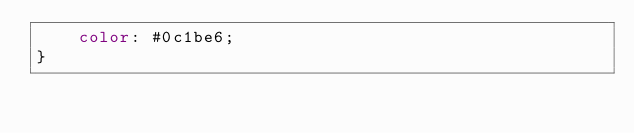Convert code to text. <code><loc_0><loc_0><loc_500><loc_500><_CSS_>    color: #0c1be6;
}</code> 